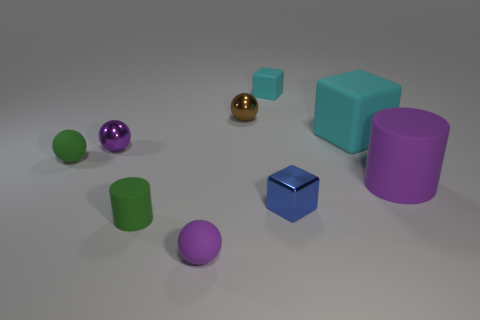Can you estimate the number of objects in the image? Certainly! In the image, there are eight objects in total, consisting of a mix of geometric shapes including cubes, spheres, and cylinders. Which color appears most frequently among these objects? The color green appears most frequently; it is featured on three objects: a small ball, a tiny cube, and a cylinder. 